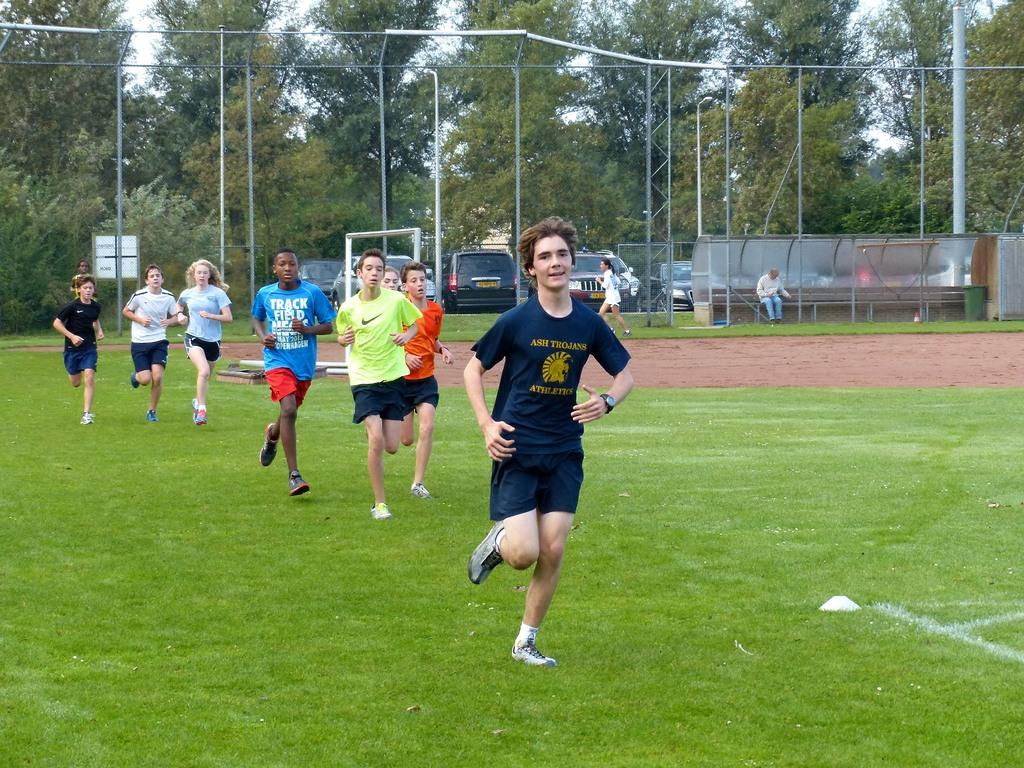<image>
Write a terse but informative summary of the picture. School kids for the Trojan athletics running on a field for practice. 